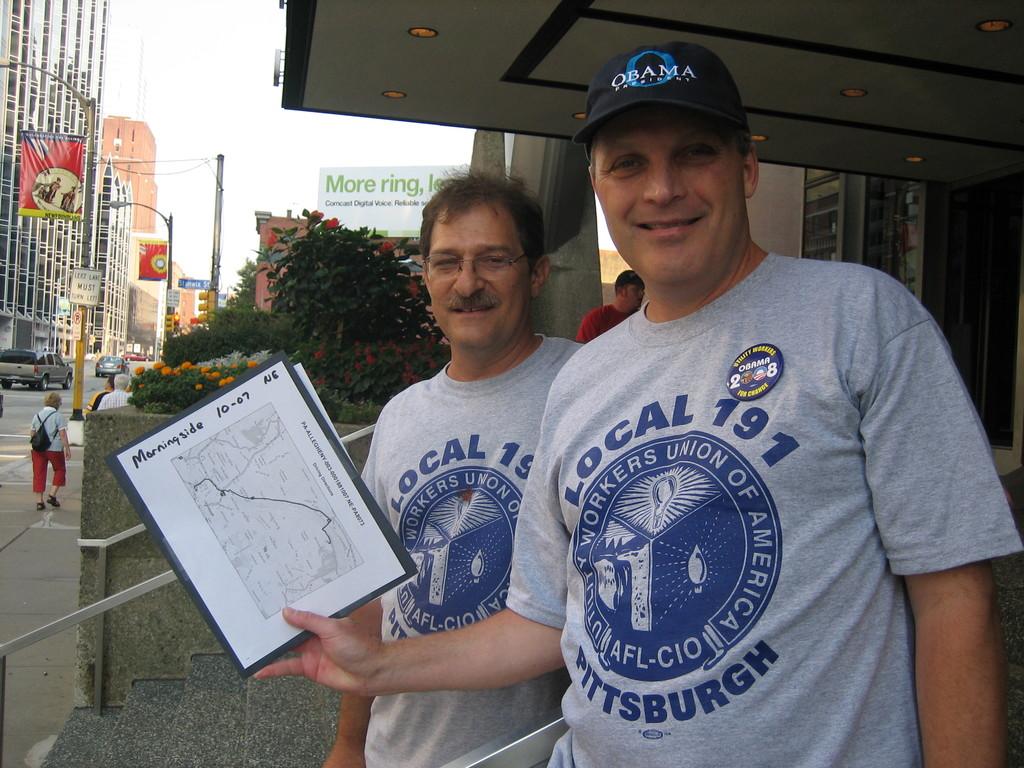What union are they with?
Make the answer very short. Local 191. What city is local 191 in ?
Your answer should be very brief. Pittsburgh. 